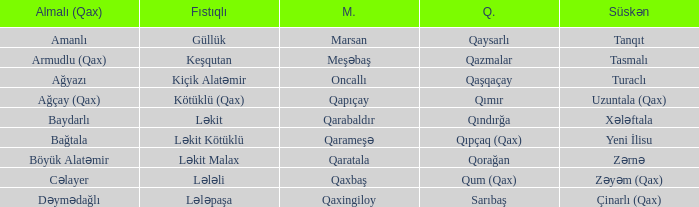What is the Qaxmuğal village with a Malax village meşəbaş? Qazmalar. 